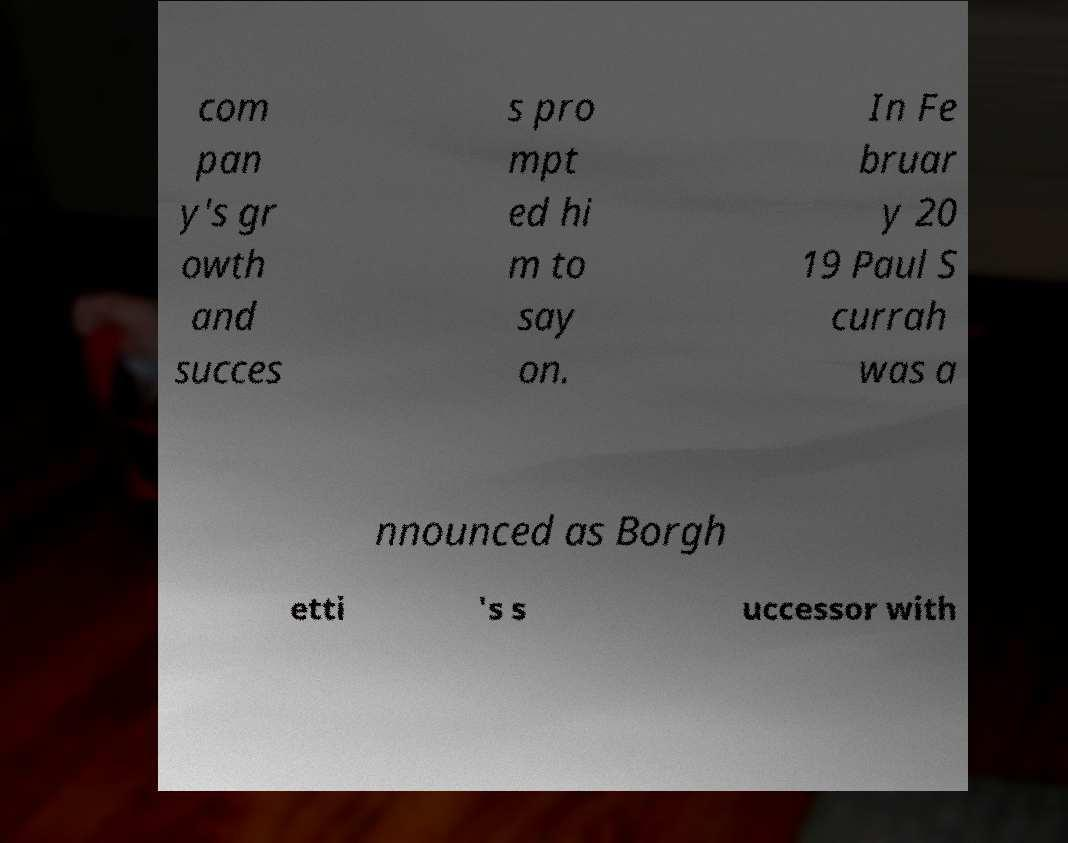Can you accurately transcribe the text from the provided image for me? com pan y's gr owth and succes s pro mpt ed hi m to say on. In Fe bruar y 20 19 Paul S currah was a nnounced as Borgh etti 's s uccessor with 